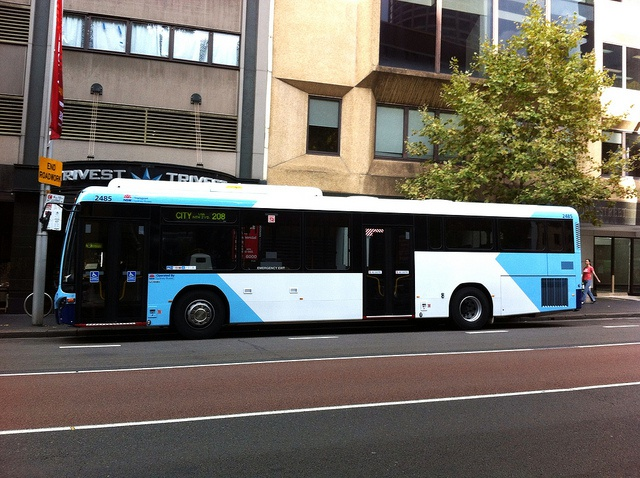Describe the objects in this image and their specific colors. I can see bus in gray, black, white, and lightblue tones and people in gray, black, and maroon tones in this image. 